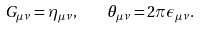<formula> <loc_0><loc_0><loc_500><loc_500>G _ { \mu \nu } = \eta _ { \mu \nu } , \quad \theta _ { \mu \nu } = 2 \pi \epsilon _ { \mu \nu } .</formula> 